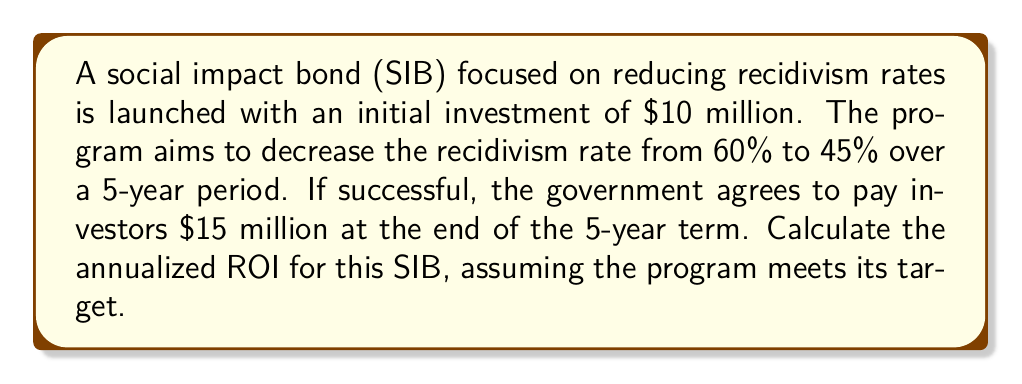Show me your answer to this math problem. To calculate the annualized Return on Investment (ROI) for this social impact bond, we'll follow these steps:

1. Calculate the total return:
   Total return = Final payment - Initial investment
   $$\text{Total return} = \$15,000,000 - \$10,000,000 = \$5,000,000$$

2. Calculate the simple ROI:
   $$\text{Simple ROI} = \frac{\text{Total return}}{\text{Initial investment}} \times 100\%$$
   $$\text{Simple ROI} = \frac{\$5,000,000}{\$10,000,000} \times 100\% = 50\%$$

3. Calculate the annualized ROI using the compound annual growth rate (CAGR) formula:
   $$\text{Annualized ROI} = \left(\frac{\text{Final Value}}{\text{Initial Value}}\right)^{\frac{1}{n}} - 1$$
   
   Where:
   - Final Value = $15,000,000
   - Initial Value = $10,000,000
   - n = 5 years

   $$\text{Annualized ROI} = \left(\frac{\$15,000,000}{\$10,000,000}\right)^{\frac{1}{5}} - 1$$
   $$\text{Annualized ROI} = (1.5)^{0.2} - 1$$
   $$\text{Annualized ROI} = 1.0845 - 1 = 0.0845$$

4. Convert to percentage:
   $$\text{Annualized ROI} = 0.0845 \times 100\% = 8.45\%$$

Therefore, the annualized ROI for this social impact bond is 8.45%.
Answer: The annualized ROI for the social impact bond is 8.45%. 